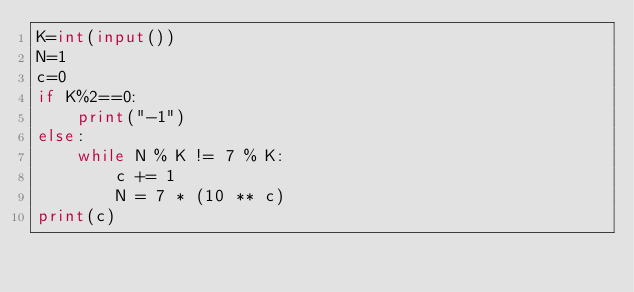Convert code to text. <code><loc_0><loc_0><loc_500><loc_500><_Python_>K=int(input())
N=1
c=0
if K%2==0:
    print("-1")
else:
    while N % K != 7 % K:
        c += 1
        N = 7 * (10 ** c)
print(c)</code> 